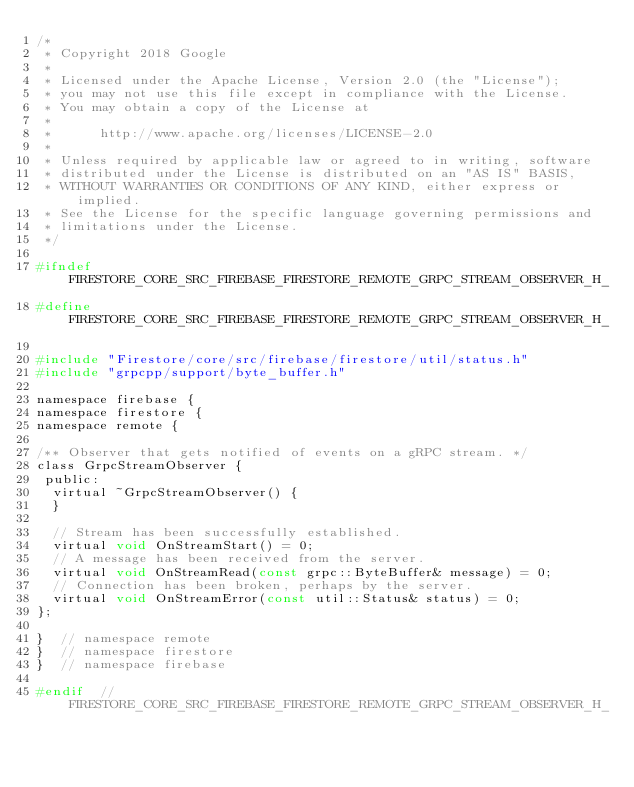Convert code to text. <code><loc_0><loc_0><loc_500><loc_500><_C_>/*
 * Copyright 2018 Google
 *
 * Licensed under the Apache License, Version 2.0 (the "License");
 * you may not use this file except in compliance with the License.
 * You may obtain a copy of the License at
 *
 *      http://www.apache.org/licenses/LICENSE-2.0
 *
 * Unless required by applicable law or agreed to in writing, software
 * distributed under the License is distributed on an "AS IS" BASIS,
 * WITHOUT WARRANTIES OR CONDITIONS OF ANY KIND, either express or implied.
 * See the License for the specific language governing permissions and
 * limitations under the License.
 */

#ifndef FIRESTORE_CORE_SRC_FIREBASE_FIRESTORE_REMOTE_GRPC_STREAM_OBSERVER_H_
#define FIRESTORE_CORE_SRC_FIREBASE_FIRESTORE_REMOTE_GRPC_STREAM_OBSERVER_H_

#include "Firestore/core/src/firebase/firestore/util/status.h"
#include "grpcpp/support/byte_buffer.h"

namespace firebase {
namespace firestore {
namespace remote {

/** Observer that gets notified of events on a gRPC stream. */
class GrpcStreamObserver {
 public:
  virtual ~GrpcStreamObserver() {
  }

  // Stream has been successfully established.
  virtual void OnStreamStart() = 0;
  // A message has been received from the server.
  virtual void OnStreamRead(const grpc::ByteBuffer& message) = 0;
  // Connection has been broken, perhaps by the server.
  virtual void OnStreamError(const util::Status& status) = 0;
};

}  // namespace remote
}  // namespace firestore
}  // namespace firebase

#endif  // FIRESTORE_CORE_SRC_FIREBASE_FIRESTORE_REMOTE_GRPC_STREAM_OBSERVER_H_
</code> 